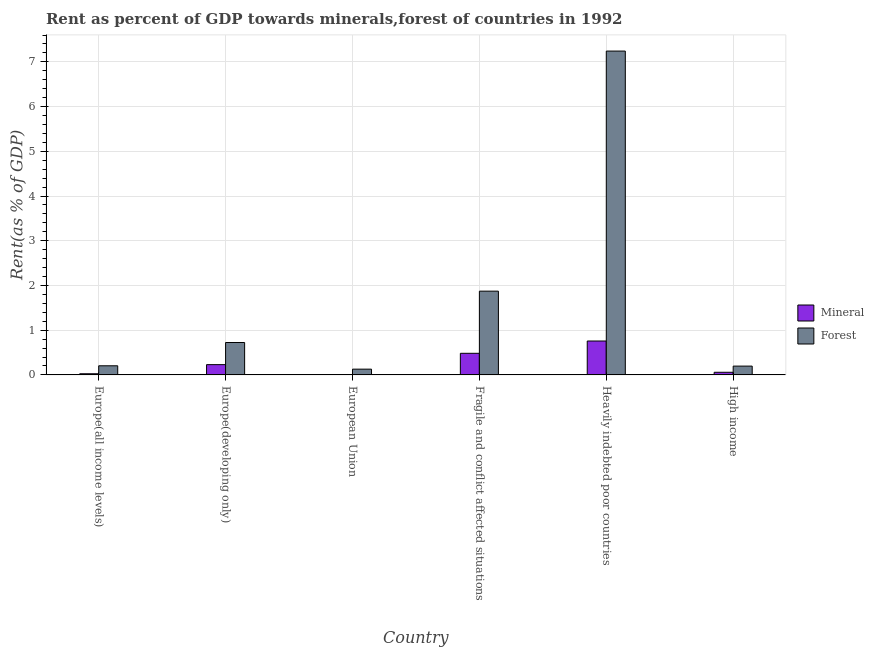How many groups of bars are there?
Your answer should be very brief. 6. How many bars are there on the 6th tick from the left?
Your answer should be very brief. 2. What is the label of the 6th group of bars from the left?
Your answer should be compact. High income. What is the forest rent in Europe(developing only)?
Make the answer very short. 0.72. Across all countries, what is the maximum forest rent?
Provide a short and direct response. 7.24. Across all countries, what is the minimum forest rent?
Offer a terse response. 0.13. In which country was the forest rent maximum?
Give a very brief answer. Heavily indebted poor countries. What is the total mineral rent in the graph?
Give a very brief answer. 1.56. What is the difference between the mineral rent in Fragile and conflict affected situations and that in High income?
Your answer should be very brief. 0.42. What is the difference between the forest rent in European Union and the mineral rent in Europe(developing only)?
Your response must be concise. -0.1. What is the average forest rent per country?
Provide a short and direct response. 1.73. What is the difference between the mineral rent and forest rent in Fragile and conflict affected situations?
Your answer should be very brief. -1.39. In how many countries, is the mineral rent greater than 1.8 %?
Your response must be concise. 0. What is the ratio of the forest rent in Heavily indebted poor countries to that in High income?
Make the answer very short. 36.78. Is the mineral rent in Europe(all income levels) less than that in Fragile and conflict affected situations?
Offer a terse response. Yes. What is the difference between the highest and the second highest mineral rent?
Offer a terse response. 0.27. What is the difference between the highest and the lowest mineral rent?
Offer a terse response. 0.75. Is the sum of the mineral rent in Europe(all income levels) and High income greater than the maximum forest rent across all countries?
Provide a short and direct response. No. What does the 1st bar from the left in Fragile and conflict affected situations represents?
Provide a short and direct response. Mineral. What does the 1st bar from the right in High income represents?
Offer a terse response. Forest. How many countries are there in the graph?
Your answer should be very brief. 6. What is the difference between two consecutive major ticks on the Y-axis?
Keep it short and to the point. 1. Are the values on the major ticks of Y-axis written in scientific E-notation?
Provide a short and direct response. No. Where does the legend appear in the graph?
Your answer should be compact. Center right. How are the legend labels stacked?
Offer a terse response. Vertical. What is the title of the graph?
Provide a succinct answer. Rent as percent of GDP towards minerals,forest of countries in 1992. Does "Overweight" appear as one of the legend labels in the graph?
Your response must be concise. No. What is the label or title of the Y-axis?
Ensure brevity in your answer.  Rent(as % of GDP). What is the Rent(as % of GDP) in Mineral in Europe(all income levels)?
Your answer should be compact. 0.03. What is the Rent(as % of GDP) of Forest in Europe(all income levels)?
Provide a succinct answer. 0.2. What is the Rent(as % of GDP) of Mineral in Europe(developing only)?
Your answer should be compact. 0.23. What is the Rent(as % of GDP) in Forest in Europe(developing only)?
Make the answer very short. 0.72. What is the Rent(as % of GDP) of Mineral in European Union?
Offer a very short reply. 0.01. What is the Rent(as % of GDP) of Forest in European Union?
Ensure brevity in your answer.  0.13. What is the Rent(as % of GDP) in Mineral in Fragile and conflict affected situations?
Your response must be concise. 0.48. What is the Rent(as % of GDP) of Forest in Fragile and conflict affected situations?
Your answer should be very brief. 1.87. What is the Rent(as % of GDP) in Mineral in Heavily indebted poor countries?
Your answer should be very brief. 0.76. What is the Rent(as % of GDP) of Forest in Heavily indebted poor countries?
Ensure brevity in your answer.  7.24. What is the Rent(as % of GDP) of Mineral in High income?
Your response must be concise. 0.06. What is the Rent(as % of GDP) in Forest in High income?
Provide a short and direct response. 0.2. Across all countries, what is the maximum Rent(as % of GDP) of Mineral?
Make the answer very short. 0.76. Across all countries, what is the maximum Rent(as % of GDP) in Forest?
Your answer should be very brief. 7.24. Across all countries, what is the minimum Rent(as % of GDP) of Mineral?
Your answer should be compact. 0.01. Across all countries, what is the minimum Rent(as % of GDP) of Forest?
Give a very brief answer. 0.13. What is the total Rent(as % of GDP) of Mineral in the graph?
Keep it short and to the point. 1.56. What is the total Rent(as % of GDP) in Forest in the graph?
Provide a short and direct response. 10.37. What is the difference between the Rent(as % of GDP) of Mineral in Europe(all income levels) and that in Europe(developing only)?
Your response must be concise. -0.2. What is the difference between the Rent(as % of GDP) in Forest in Europe(all income levels) and that in Europe(developing only)?
Keep it short and to the point. -0.52. What is the difference between the Rent(as % of GDP) in Mineral in Europe(all income levels) and that in European Union?
Offer a terse response. 0.02. What is the difference between the Rent(as % of GDP) of Forest in Europe(all income levels) and that in European Union?
Keep it short and to the point. 0.08. What is the difference between the Rent(as % of GDP) of Mineral in Europe(all income levels) and that in Fragile and conflict affected situations?
Your response must be concise. -0.46. What is the difference between the Rent(as % of GDP) in Forest in Europe(all income levels) and that in Fragile and conflict affected situations?
Offer a terse response. -1.67. What is the difference between the Rent(as % of GDP) in Mineral in Europe(all income levels) and that in Heavily indebted poor countries?
Make the answer very short. -0.73. What is the difference between the Rent(as % of GDP) in Forest in Europe(all income levels) and that in Heavily indebted poor countries?
Provide a succinct answer. -7.04. What is the difference between the Rent(as % of GDP) of Mineral in Europe(all income levels) and that in High income?
Provide a short and direct response. -0.03. What is the difference between the Rent(as % of GDP) in Forest in Europe(all income levels) and that in High income?
Keep it short and to the point. 0.01. What is the difference between the Rent(as % of GDP) of Mineral in Europe(developing only) and that in European Union?
Make the answer very short. 0.22. What is the difference between the Rent(as % of GDP) of Forest in Europe(developing only) and that in European Union?
Make the answer very short. 0.6. What is the difference between the Rent(as % of GDP) of Mineral in Europe(developing only) and that in Fragile and conflict affected situations?
Your answer should be compact. -0.25. What is the difference between the Rent(as % of GDP) in Forest in Europe(developing only) and that in Fragile and conflict affected situations?
Keep it short and to the point. -1.15. What is the difference between the Rent(as % of GDP) of Mineral in Europe(developing only) and that in Heavily indebted poor countries?
Give a very brief answer. -0.53. What is the difference between the Rent(as % of GDP) of Forest in Europe(developing only) and that in Heavily indebted poor countries?
Your answer should be very brief. -6.52. What is the difference between the Rent(as % of GDP) of Mineral in Europe(developing only) and that in High income?
Ensure brevity in your answer.  0.17. What is the difference between the Rent(as % of GDP) of Forest in Europe(developing only) and that in High income?
Offer a very short reply. 0.53. What is the difference between the Rent(as % of GDP) in Mineral in European Union and that in Fragile and conflict affected situations?
Your response must be concise. -0.48. What is the difference between the Rent(as % of GDP) in Forest in European Union and that in Fragile and conflict affected situations?
Your answer should be compact. -1.74. What is the difference between the Rent(as % of GDP) of Mineral in European Union and that in Heavily indebted poor countries?
Ensure brevity in your answer.  -0.75. What is the difference between the Rent(as % of GDP) in Forest in European Union and that in Heavily indebted poor countries?
Your answer should be compact. -7.11. What is the difference between the Rent(as % of GDP) of Mineral in European Union and that in High income?
Offer a very short reply. -0.05. What is the difference between the Rent(as % of GDP) in Forest in European Union and that in High income?
Your response must be concise. -0.07. What is the difference between the Rent(as % of GDP) of Mineral in Fragile and conflict affected situations and that in Heavily indebted poor countries?
Make the answer very short. -0.27. What is the difference between the Rent(as % of GDP) in Forest in Fragile and conflict affected situations and that in Heavily indebted poor countries?
Ensure brevity in your answer.  -5.37. What is the difference between the Rent(as % of GDP) of Mineral in Fragile and conflict affected situations and that in High income?
Your answer should be very brief. 0.42. What is the difference between the Rent(as % of GDP) in Forest in Fragile and conflict affected situations and that in High income?
Ensure brevity in your answer.  1.68. What is the difference between the Rent(as % of GDP) of Mineral in Heavily indebted poor countries and that in High income?
Your answer should be very brief. 0.7. What is the difference between the Rent(as % of GDP) of Forest in Heavily indebted poor countries and that in High income?
Your answer should be very brief. 7.04. What is the difference between the Rent(as % of GDP) in Mineral in Europe(all income levels) and the Rent(as % of GDP) in Forest in Europe(developing only)?
Offer a terse response. -0.7. What is the difference between the Rent(as % of GDP) of Mineral in Europe(all income levels) and the Rent(as % of GDP) of Forest in European Union?
Keep it short and to the point. -0.1. What is the difference between the Rent(as % of GDP) in Mineral in Europe(all income levels) and the Rent(as % of GDP) in Forest in Fragile and conflict affected situations?
Give a very brief answer. -1.85. What is the difference between the Rent(as % of GDP) of Mineral in Europe(all income levels) and the Rent(as % of GDP) of Forest in Heavily indebted poor countries?
Your answer should be very brief. -7.22. What is the difference between the Rent(as % of GDP) of Mineral in Europe(all income levels) and the Rent(as % of GDP) of Forest in High income?
Provide a short and direct response. -0.17. What is the difference between the Rent(as % of GDP) of Mineral in Europe(developing only) and the Rent(as % of GDP) of Forest in European Union?
Your answer should be very brief. 0.1. What is the difference between the Rent(as % of GDP) of Mineral in Europe(developing only) and the Rent(as % of GDP) of Forest in Fragile and conflict affected situations?
Offer a terse response. -1.64. What is the difference between the Rent(as % of GDP) in Mineral in Europe(developing only) and the Rent(as % of GDP) in Forest in Heavily indebted poor countries?
Provide a short and direct response. -7.01. What is the difference between the Rent(as % of GDP) of Mineral in Europe(developing only) and the Rent(as % of GDP) of Forest in High income?
Your response must be concise. 0.03. What is the difference between the Rent(as % of GDP) in Mineral in European Union and the Rent(as % of GDP) in Forest in Fragile and conflict affected situations?
Ensure brevity in your answer.  -1.86. What is the difference between the Rent(as % of GDP) of Mineral in European Union and the Rent(as % of GDP) of Forest in Heavily indebted poor countries?
Keep it short and to the point. -7.23. What is the difference between the Rent(as % of GDP) in Mineral in European Union and the Rent(as % of GDP) in Forest in High income?
Offer a very short reply. -0.19. What is the difference between the Rent(as % of GDP) of Mineral in Fragile and conflict affected situations and the Rent(as % of GDP) of Forest in Heavily indebted poor countries?
Provide a short and direct response. -6.76. What is the difference between the Rent(as % of GDP) in Mineral in Fragile and conflict affected situations and the Rent(as % of GDP) in Forest in High income?
Offer a terse response. 0.29. What is the difference between the Rent(as % of GDP) in Mineral in Heavily indebted poor countries and the Rent(as % of GDP) in Forest in High income?
Your answer should be compact. 0.56. What is the average Rent(as % of GDP) in Mineral per country?
Offer a very short reply. 0.26. What is the average Rent(as % of GDP) in Forest per country?
Provide a short and direct response. 1.73. What is the difference between the Rent(as % of GDP) in Mineral and Rent(as % of GDP) in Forest in Europe(all income levels)?
Your answer should be very brief. -0.18. What is the difference between the Rent(as % of GDP) in Mineral and Rent(as % of GDP) in Forest in Europe(developing only)?
Provide a succinct answer. -0.49. What is the difference between the Rent(as % of GDP) of Mineral and Rent(as % of GDP) of Forest in European Union?
Make the answer very short. -0.12. What is the difference between the Rent(as % of GDP) of Mineral and Rent(as % of GDP) of Forest in Fragile and conflict affected situations?
Your answer should be very brief. -1.39. What is the difference between the Rent(as % of GDP) of Mineral and Rent(as % of GDP) of Forest in Heavily indebted poor countries?
Provide a short and direct response. -6.48. What is the difference between the Rent(as % of GDP) of Mineral and Rent(as % of GDP) of Forest in High income?
Give a very brief answer. -0.14. What is the ratio of the Rent(as % of GDP) in Mineral in Europe(all income levels) to that in Europe(developing only)?
Ensure brevity in your answer.  0.11. What is the ratio of the Rent(as % of GDP) in Forest in Europe(all income levels) to that in Europe(developing only)?
Keep it short and to the point. 0.28. What is the ratio of the Rent(as % of GDP) in Mineral in Europe(all income levels) to that in European Union?
Offer a very short reply. 3.34. What is the ratio of the Rent(as % of GDP) in Forest in Europe(all income levels) to that in European Union?
Your response must be concise. 1.58. What is the ratio of the Rent(as % of GDP) in Mineral in Europe(all income levels) to that in Fragile and conflict affected situations?
Offer a very short reply. 0.05. What is the ratio of the Rent(as % of GDP) of Forest in Europe(all income levels) to that in Fragile and conflict affected situations?
Offer a terse response. 0.11. What is the ratio of the Rent(as % of GDP) in Mineral in Europe(all income levels) to that in Heavily indebted poor countries?
Your answer should be compact. 0.03. What is the ratio of the Rent(as % of GDP) of Forest in Europe(all income levels) to that in Heavily indebted poor countries?
Offer a very short reply. 0.03. What is the ratio of the Rent(as % of GDP) of Mineral in Europe(all income levels) to that in High income?
Offer a terse response. 0.44. What is the ratio of the Rent(as % of GDP) in Forest in Europe(all income levels) to that in High income?
Keep it short and to the point. 1.04. What is the ratio of the Rent(as % of GDP) of Mineral in Europe(developing only) to that in European Union?
Make the answer very short. 29.86. What is the ratio of the Rent(as % of GDP) in Forest in Europe(developing only) to that in European Union?
Offer a very short reply. 5.62. What is the ratio of the Rent(as % of GDP) of Mineral in Europe(developing only) to that in Fragile and conflict affected situations?
Offer a very short reply. 0.48. What is the ratio of the Rent(as % of GDP) in Forest in Europe(developing only) to that in Fragile and conflict affected situations?
Your answer should be very brief. 0.39. What is the ratio of the Rent(as % of GDP) of Mineral in Europe(developing only) to that in Heavily indebted poor countries?
Make the answer very short. 0.3. What is the ratio of the Rent(as % of GDP) of Forest in Europe(developing only) to that in Heavily indebted poor countries?
Make the answer very short. 0.1. What is the ratio of the Rent(as % of GDP) in Mineral in Europe(developing only) to that in High income?
Your answer should be very brief. 3.89. What is the ratio of the Rent(as % of GDP) in Forest in Europe(developing only) to that in High income?
Provide a succinct answer. 3.68. What is the ratio of the Rent(as % of GDP) of Mineral in European Union to that in Fragile and conflict affected situations?
Keep it short and to the point. 0.02. What is the ratio of the Rent(as % of GDP) in Forest in European Union to that in Fragile and conflict affected situations?
Offer a terse response. 0.07. What is the ratio of the Rent(as % of GDP) of Mineral in European Union to that in Heavily indebted poor countries?
Your response must be concise. 0.01. What is the ratio of the Rent(as % of GDP) in Forest in European Union to that in Heavily indebted poor countries?
Provide a succinct answer. 0.02. What is the ratio of the Rent(as % of GDP) of Mineral in European Union to that in High income?
Give a very brief answer. 0.13. What is the ratio of the Rent(as % of GDP) of Forest in European Union to that in High income?
Ensure brevity in your answer.  0.66. What is the ratio of the Rent(as % of GDP) in Mineral in Fragile and conflict affected situations to that in Heavily indebted poor countries?
Make the answer very short. 0.64. What is the ratio of the Rent(as % of GDP) of Forest in Fragile and conflict affected situations to that in Heavily indebted poor countries?
Offer a terse response. 0.26. What is the ratio of the Rent(as % of GDP) of Mineral in Fragile and conflict affected situations to that in High income?
Offer a terse response. 8.18. What is the ratio of the Rent(as % of GDP) of Forest in Fragile and conflict affected situations to that in High income?
Your answer should be compact. 9.51. What is the ratio of the Rent(as % of GDP) of Mineral in Heavily indebted poor countries to that in High income?
Your answer should be compact. 12.83. What is the ratio of the Rent(as % of GDP) in Forest in Heavily indebted poor countries to that in High income?
Your answer should be compact. 36.78. What is the difference between the highest and the second highest Rent(as % of GDP) of Mineral?
Ensure brevity in your answer.  0.27. What is the difference between the highest and the second highest Rent(as % of GDP) in Forest?
Offer a terse response. 5.37. What is the difference between the highest and the lowest Rent(as % of GDP) in Mineral?
Make the answer very short. 0.75. What is the difference between the highest and the lowest Rent(as % of GDP) in Forest?
Make the answer very short. 7.11. 